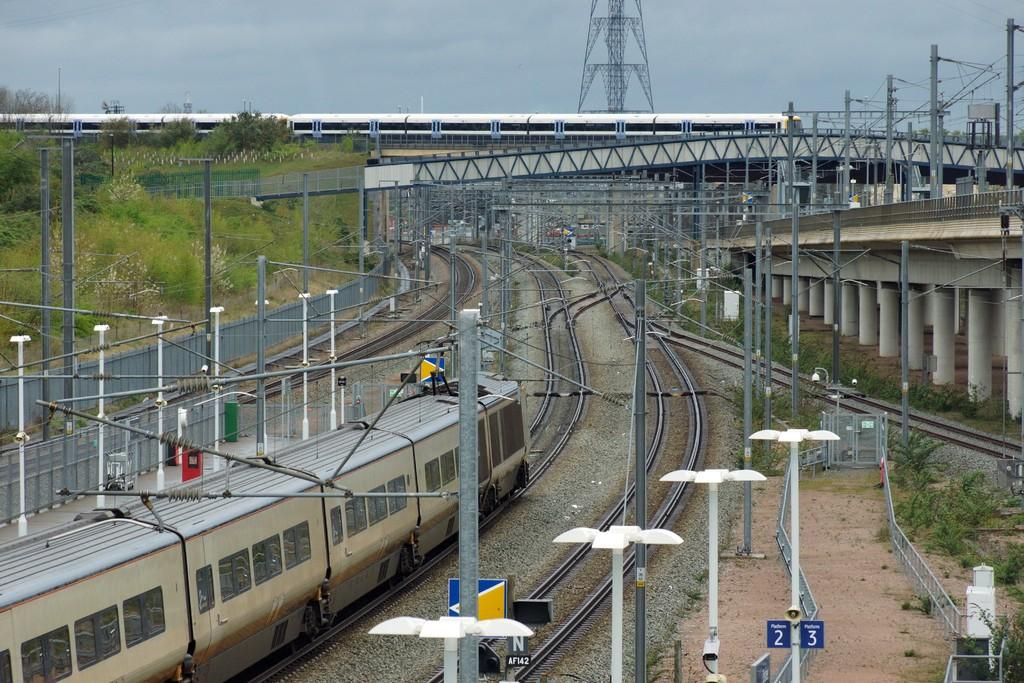<image>
Create a compact narrative representing the image presented. Train parked next to a blue sign which says 2 and 3. 